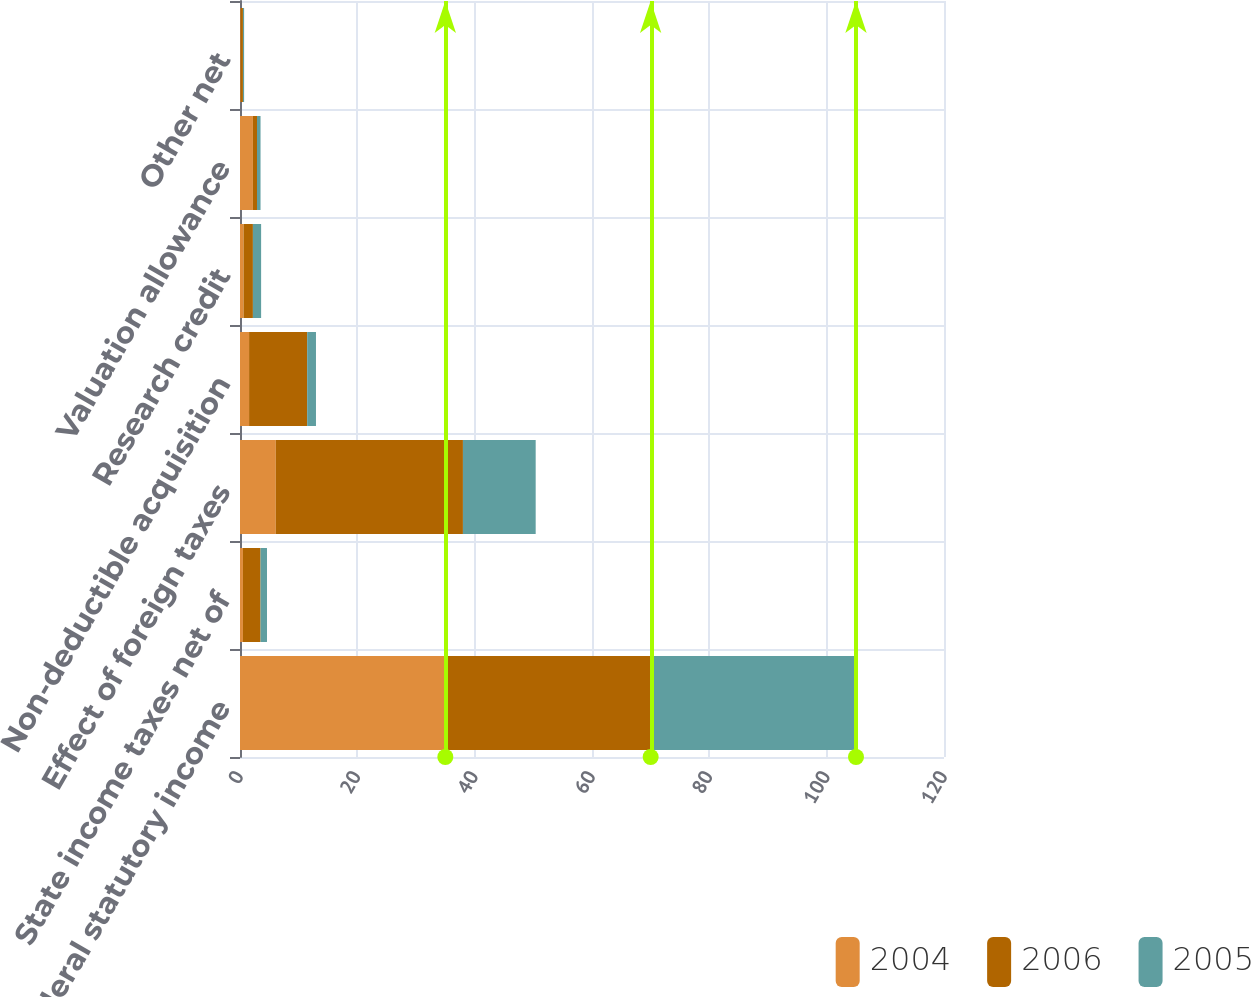Convert chart to OTSL. <chart><loc_0><loc_0><loc_500><loc_500><stacked_bar_chart><ecel><fcel>US federal statutory income<fcel>State income taxes net of<fcel>Effect of foreign taxes<fcel>Non-deductible acquisition<fcel>Research credit<fcel>Valuation allowance<fcel>Other net<nl><fcel>2004<fcel>35<fcel>0.5<fcel>6.1<fcel>1.55<fcel>0.6<fcel>2.2<fcel>0.1<nl><fcel>2006<fcel>35<fcel>3<fcel>31.9<fcel>9.9<fcel>1.6<fcel>0.7<fcel>0.4<nl><fcel>2005<fcel>35<fcel>1.1<fcel>12.4<fcel>1.5<fcel>1.4<fcel>0.6<fcel>0.2<nl></chart> 